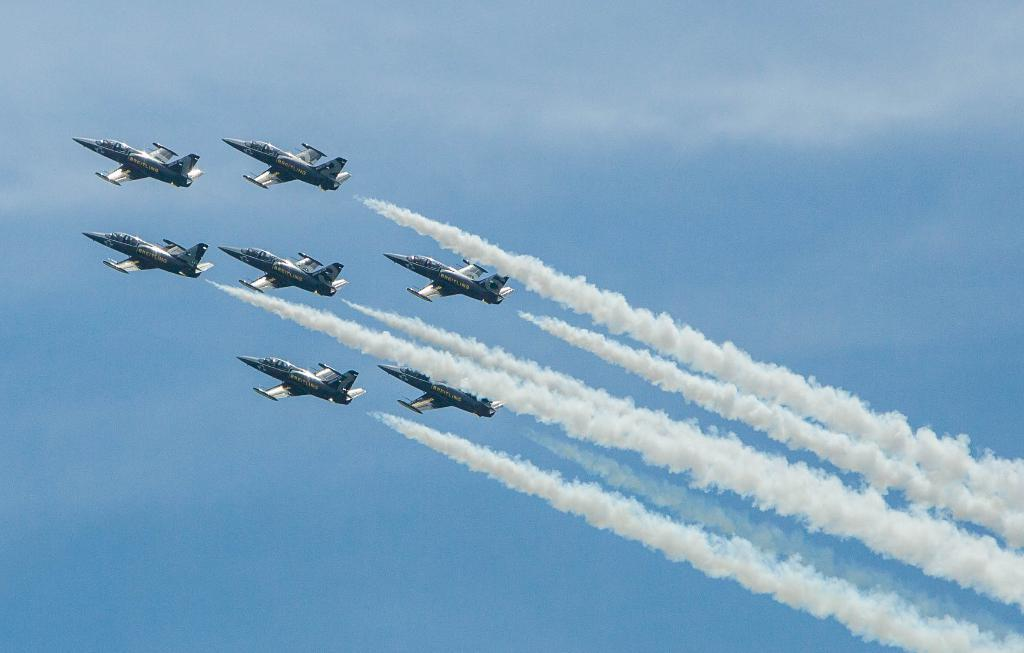What type of vehicles are in the image? There are jet planes in the image. What colors are the jet planes? The jet planes are blue and white in color. What are the jet planes doing in the image? The jet planes are flying in the air. What can be seen behind the jet planes? There is smoke visible behind the jet planes. What is visible in the background of the image? The sky is visible in the background of the image. How many cakes are being transported by the jet planes in the image? There are no cakes visible in the image, and the jet planes are not transporting any cakes. What type of face can be seen on the jet planes in the image? There are no faces visible on the jet planes in the image; they are aircraft without human features. 